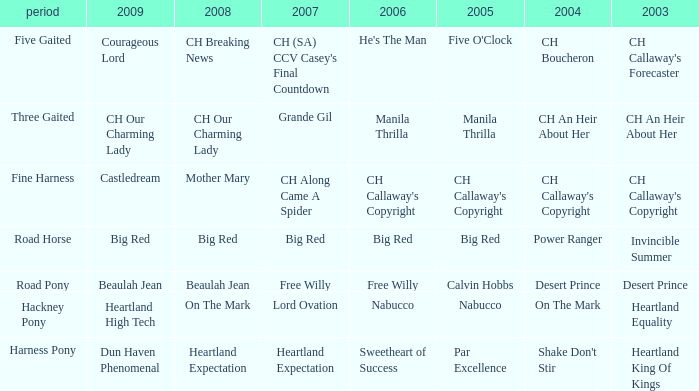What is the 2007 with ch callaway's copyright in 2003? CH Along Came A Spider. 